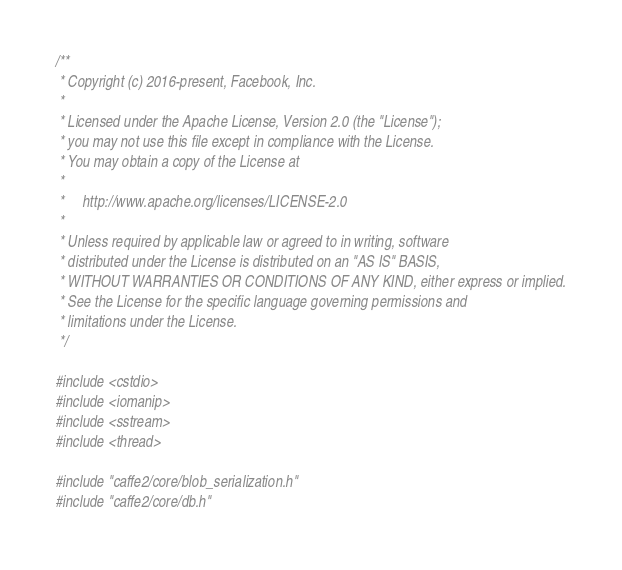Convert code to text. <code><loc_0><loc_0><loc_500><loc_500><_C++_>/**
 * Copyright (c) 2016-present, Facebook, Inc.
 *
 * Licensed under the Apache License, Version 2.0 (the "License");
 * you may not use this file except in compliance with the License.
 * You may obtain a copy of the License at
 *
 *     http://www.apache.org/licenses/LICENSE-2.0
 *
 * Unless required by applicable law or agreed to in writing, software
 * distributed under the License is distributed on an "AS IS" BASIS,
 * WITHOUT WARRANTIES OR CONDITIONS OF ANY KIND, either express or implied.
 * See the License for the specific language governing permissions and
 * limitations under the License.
 */

#include <cstdio>
#include <iomanip>
#include <sstream>
#include <thread>

#include "caffe2/core/blob_serialization.h"
#include "caffe2/core/db.h"</code> 